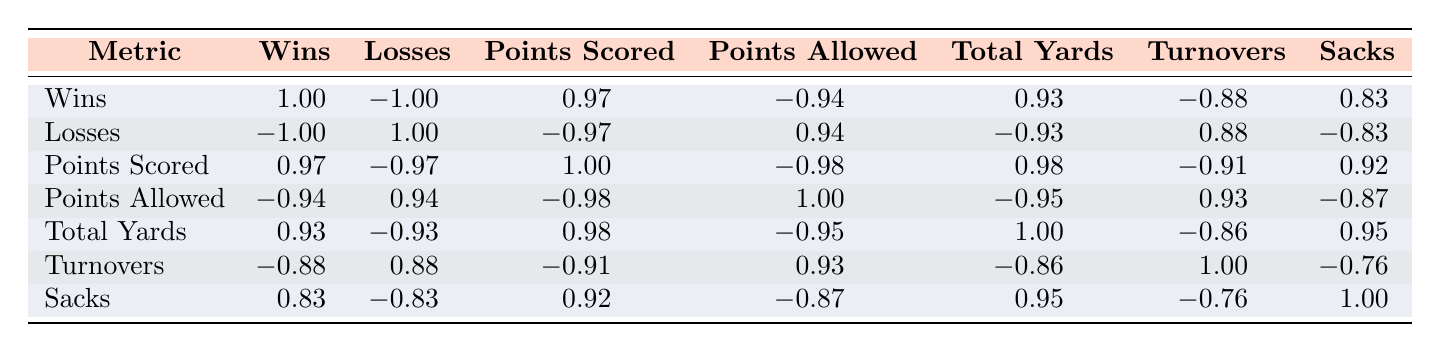What is the total number of wins by the Cleveland Browns? The table lists that the Cleveland Browns had 10 wins in the 2023 season.
Answer: 10 How many points did the Seattle Seahawks score in 2023? According to the table, the Seattle Seahawks scored 370 points in the 2023 season.
Answer: 370 What is the correlation between wins and total yards? The correlation value for wins and total yards is 0.93, indicating a strong positive relationship.
Answer: 0.93 Did the Baltimore Ravens allow more points than the Pittsburgh Steelers in the 2023 season? The table shows that the Ravens allowed 290 points, whereas the Steelers allowed 320 points. Since 290 is less than 320, this statement is false.
Answer: No What are the average points scored among all teams listed? Adding the points scored: 380 (Browns) + 370 (Seahawks) + 410 (Steelers) + 440 (Ravens) + 460 (49ers) = 2060. There are 5 teams, so the average is 2060/5 = 412.
Answer: 412 How many total sacks did the 49ers and Ravens achieve combined? The 49ers recorded 55 sacks and the Ravens recorded 48. Adding these gives 55 + 48 = 103 total sacks.
Answer: 103 Is it true that teams with fewer allowed points generally win more games? Looking at the correlations, the values for wins and points allowed is -0.94, suggesting that as points allowed decreases, wins tend to increase. Thus, the statement is true.
Answer: Yes What is the difference in points scored between the 49ers and the Ravens? The 49ers scored 460 points while the Ravens scored 440 points. The difference is calculated as 460 - 440 = 20.
Answer: 20 How many turnovers did the team with the most wins have? The team with the most wins is the Baltimore Ravens with 12 total turnovers, as shown in the table.
Answer: 8 